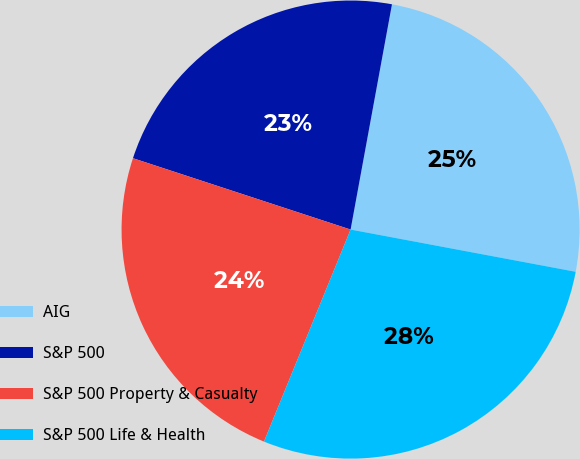Convert chart. <chart><loc_0><loc_0><loc_500><loc_500><pie_chart><fcel>AIG<fcel>S&P 500<fcel>S&P 500 Property & Casualty<fcel>S&P 500 Life & Health<nl><fcel>25.06%<fcel>22.85%<fcel>23.87%<fcel>28.22%<nl></chart> 